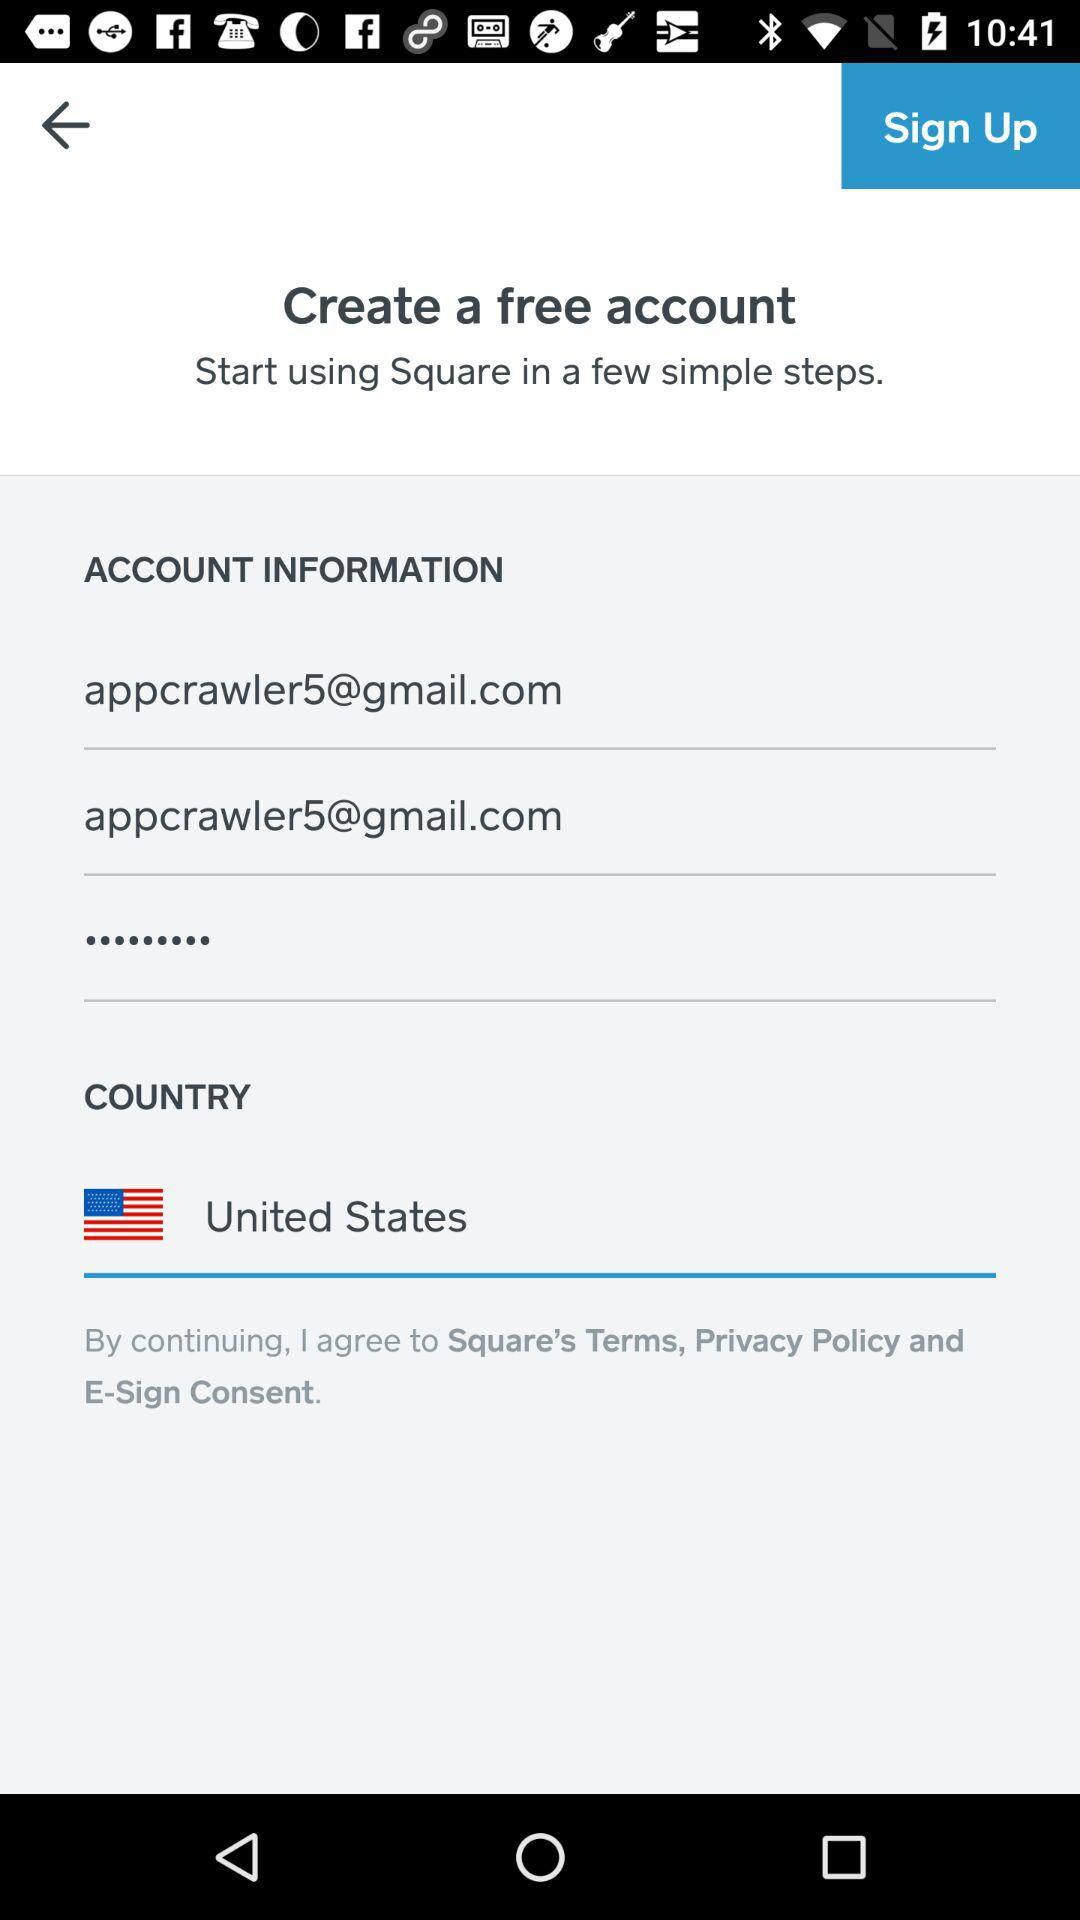What is the country name? The country name is the United States. 